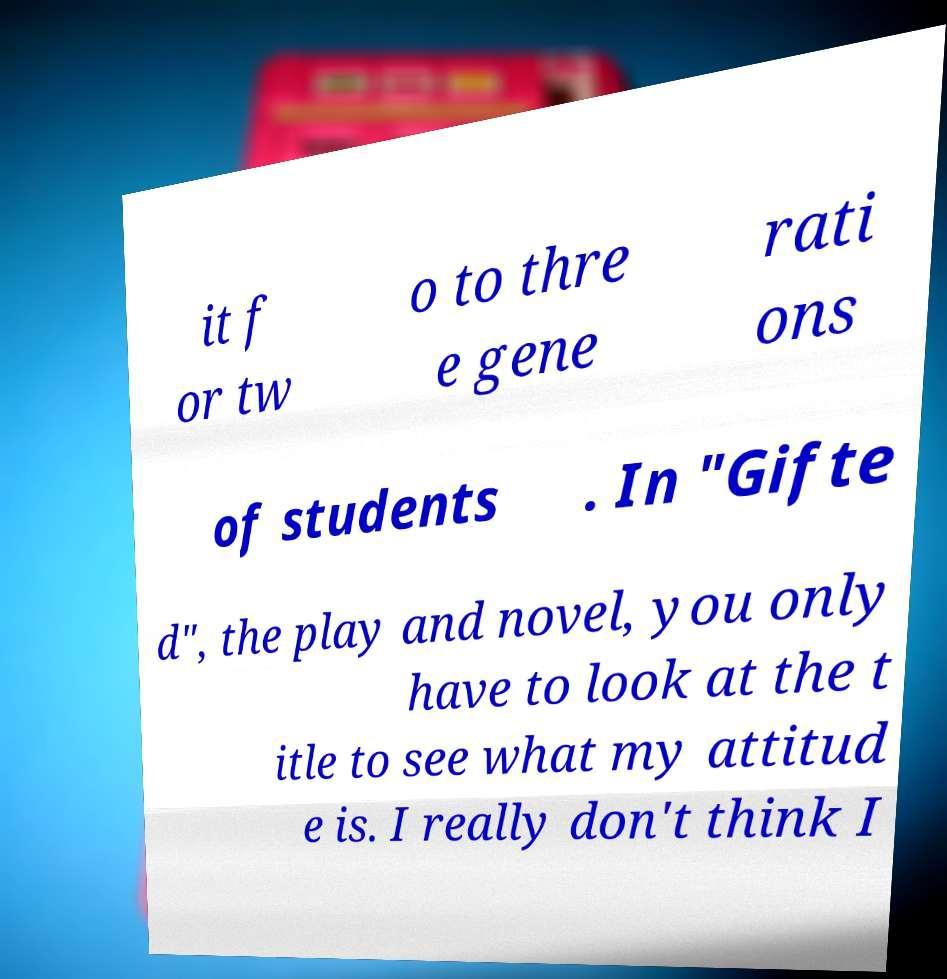Can you read and provide the text displayed in the image?This photo seems to have some interesting text. Can you extract and type it out for me? it f or tw o to thre e gene rati ons of students . In "Gifte d", the play and novel, you only have to look at the t itle to see what my attitud e is. I really don't think I 